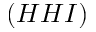<formula> <loc_0><loc_0><loc_500><loc_500>( H H I )</formula> 